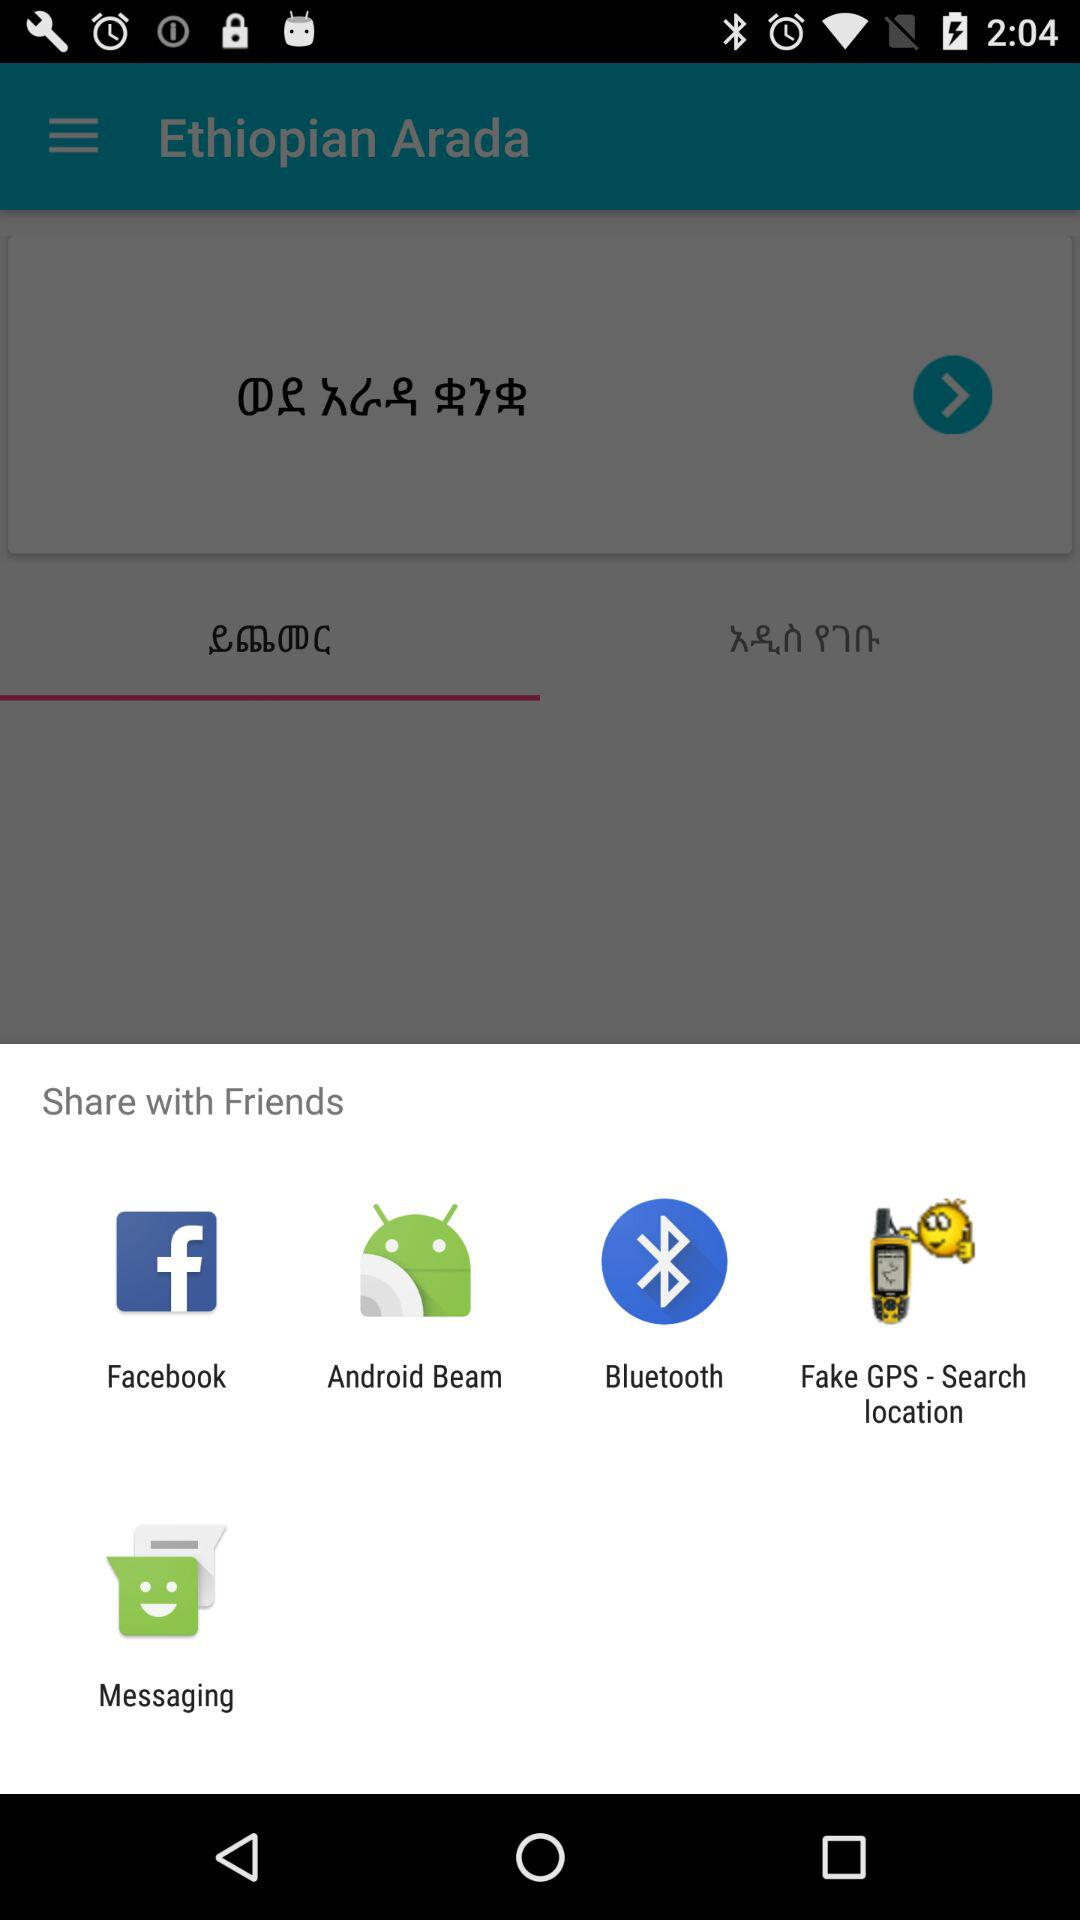What are the sharing options? The sharing options are "Facebook", "Android Beam", "Bluetooth", "Fake GPS Search location" and "Messaging". 